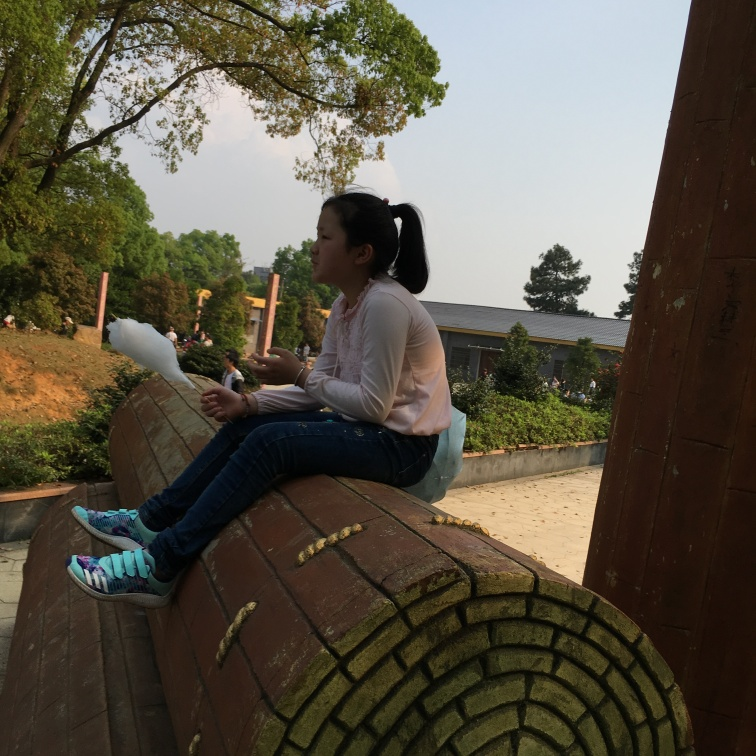What is the subject doing in this image? The subject appears to be sitting on a curved structure, possibly enjoying a moment of leisure. She seems to be holding something in her left hand, which could be a snack or a small personal item. 